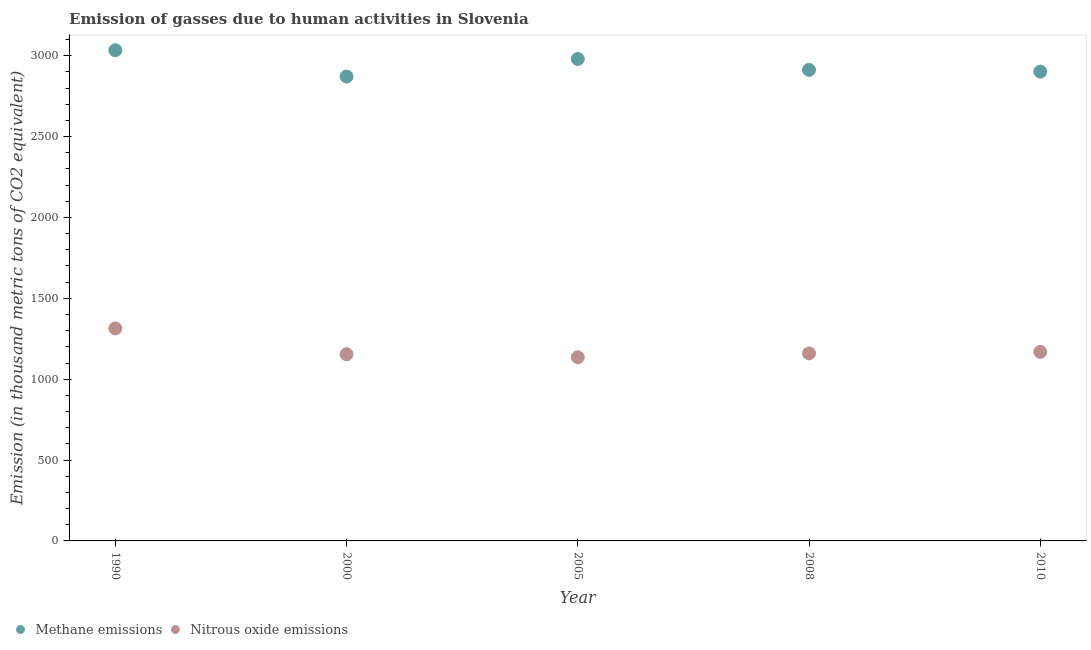How many different coloured dotlines are there?
Your response must be concise. 2. Is the number of dotlines equal to the number of legend labels?
Your response must be concise. Yes. What is the amount of methane emissions in 2010?
Offer a terse response. 2901.7. Across all years, what is the maximum amount of nitrous oxide emissions?
Keep it short and to the point. 1313.9. Across all years, what is the minimum amount of methane emissions?
Ensure brevity in your answer.  2871.1. What is the total amount of nitrous oxide emissions in the graph?
Your answer should be very brief. 5932. What is the difference between the amount of nitrous oxide emissions in 1990 and the amount of methane emissions in 2005?
Make the answer very short. -1666. What is the average amount of nitrous oxide emissions per year?
Ensure brevity in your answer.  1186.4. In the year 2005, what is the difference between the amount of nitrous oxide emissions and amount of methane emissions?
Your answer should be compact. -1844.2. What is the ratio of the amount of methane emissions in 2000 to that in 2010?
Keep it short and to the point. 0.99. Is the amount of nitrous oxide emissions in 2005 less than that in 2010?
Your answer should be very brief. Yes. What is the difference between the highest and the second highest amount of methane emissions?
Your response must be concise. 54. What is the difference between the highest and the lowest amount of methane emissions?
Offer a very short reply. 162.8. Does the amount of nitrous oxide emissions monotonically increase over the years?
Your response must be concise. No. Is the amount of nitrous oxide emissions strictly greater than the amount of methane emissions over the years?
Give a very brief answer. No. Is the amount of nitrous oxide emissions strictly less than the amount of methane emissions over the years?
Provide a short and direct response. Yes. How many years are there in the graph?
Offer a very short reply. 5. Where does the legend appear in the graph?
Offer a terse response. Bottom left. How many legend labels are there?
Offer a terse response. 2. How are the legend labels stacked?
Offer a very short reply. Horizontal. What is the title of the graph?
Keep it short and to the point. Emission of gasses due to human activities in Slovenia. What is the label or title of the Y-axis?
Provide a succinct answer. Emission (in thousand metric tons of CO2 equivalent). What is the Emission (in thousand metric tons of CO2 equivalent) in Methane emissions in 1990?
Your answer should be compact. 3033.9. What is the Emission (in thousand metric tons of CO2 equivalent) of Nitrous oxide emissions in 1990?
Offer a terse response. 1313.9. What is the Emission (in thousand metric tons of CO2 equivalent) of Methane emissions in 2000?
Give a very brief answer. 2871.1. What is the Emission (in thousand metric tons of CO2 equivalent) in Nitrous oxide emissions in 2000?
Offer a terse response. 1154.3. What is the Emission (in thousand metric tons of CO2 equivalent) in Methane emissions in 2005?
Your answer should be very brief. 2979.9. What is the Emission (in thousand metric tons of CO2 equivalent) in Nitrous oxide emissions in 2005?
Make the answer very short. 1135.7. What is the Emission (in thousand metric tons of CO2 equivalent) in Methane emissions in 2008?
Provide a short and direct response. 2912.5. What is the Emission (in thousand metric tons of CO2 equivalent) in Nitrous oxide emissions in 2008?
Give a very brief answer. 1159.5. What is the Emission (in thousand metric tons of CO2 equivalent) in Methane emissions in 2010?
Offer a very short reply. 2901.7. What is the Emission (in thousand metric tons of CO2 equivalent) of Nitrous oxide emissions in 2010?
Offer a very short reply. 1168.6. Across all years, what is the maximum Emission (in thousand metric tons of CO2 equivalent) in Methane emissions?
Your answer should be compact. 3033.9. Across all years, what is the maximum Emission (in thousand metric tons of CO2 equivalent) in Nitrous oxide emissions?
Ensure brevity in your answer.  1313.9. Across all years, what is the minimum Emission (in thousand metric tons of CO2 equivalent) of Methane emissions?
Your answer should be very brief. 2871.1. Across all years, what is the minimum Emission (in thousand metric tons of CO2 equivalent) in Nitrous oxide emissions?
Offer a very short reply. 1135.7. What is the total Emission (in thousand metric tons of CO2 equivalent) in Methane emissions in the graph?
Your answer should be very brief. 1.47e+04. What is the total Emission (in thousand metric tons of CO2 equivalent) in Nitrous oxide emissions in the graph?
Provide a succinct answer. 5932. What is the difference between the Emission (in thousand metric tons of CO2 equivalent) in Methane emissions in 1990 and that in 2000?
Offer a terse response. 162.8. What is the difference between the Emission (in thousand metric tons of CO2 equivalent) of Nitrous oxide emissions in 1990 and that in 2000?
Your answer should be compact. 159.6. What is the difference between the Emission (in thousand metric tons of CO2 equivalent) of Methane emissions in 1990 and that in 2005?
Your response must be concise. 54. What is the difference between the Emission (in thousand metric tons of CO2 equivalent) in Nitrous oxide emissions in 1990 and that in 2005?
Make the answer very short. 178.2. What is the difference between the Emission (in thousand metric tons of CO2 equivalent) of Methane emissions in 1990 and that in 2008?
Your response must be concise. 121.4. What is the difference between the Emission (in thousand metric tons of CO2 equivalent) of Nitrous oxide emissions in 1990 and that in 2008?
Your answer should be very brief. 154.4. What is the difference between the Emission (in thousand metric tons of CO2 equivalent) in Methane emissions in 1990 and that in 2010?
Ensure brevity in your answer.  132.2. What is the difference between the Emission (in thousand metric tons of CO2 equivalent) in Nitrous oxide emissions in 1990 and that in 2010?
Ensure brevity in your answer.  145.3. What is the difference between the Emission (in thousand metric tons of CO2 equivalent) in Methane emissions in 2000 and that in 2005?
Make the answer very short. -108.8. What is the difference between the Emission (in thousand metric tons of CO2 equivalent) of Methane emissions in 2000 and that in 2008?
Give a very brief answer. -41.4. What is the difference between the Emission (in thousand metric tons of CO2 equivalent) of Methane emissions in 2000 and that in 2010?
Your response must be concise. -30.6. What is the difference between the Emission (in thousand metric tons of CO2 equivalent) of Nitrous oxide emissions in 2000 and that in 2010?
Give a very brief answer. -14.3. What is the difference between the Emission (in thousand metric tons of CO2 equivalent) in Methane emissions in 2005 and that in 2008?
Your answer should be compact. 67.4. What is the difference between the Emission (in thousand metric tons of CO2 equivalent) in Nitrous oxide emissions in 2005 and that in 2008?
Ensure brevity in your answer.  -23.8. What is the difference between the Emission (in thousand metric tons of CO2 equivalent) of Methane emissions in 2005 and that in 2010?
Provide a succinct answer. 78.2. What is the difference between the Emission (in thousand metric tons of CO2 equivalent) in Nitrous oxide emissions in 2005 and that in 2010?
Ensure brevity in your answer.  -32.9. What is the difference between the Emission (in thousand metric tons of CO2 equivalent) in Methane emissions in 1990 and the Emission (in thousand metric tons of CO2 equivalent) in Nitrous oxide emissions in 2000?
Provide a succinct answer. 1879.6. What is the difference between the Emission (in thousand metric tons of CO2 equivalent) of Methane emissions in 1990 and the Emission (in thousand metric tons of CO2 equivalent) of Nitrous oxide emissions in 2005?
Provide a succinct answer. 1898.2. What is the difference between the Emission (in thousand metric tons of CO2 equivalent) of Methane emissions in 1990 and the Emission (in thousand metric tons of CO2 equivalent) of Nitrous oxide emissions in 2008?
Offer a terse response. 1874.4. What is the difference between the Emission (in thousand metric tons of CO2 equivalent) in Methane emissions in 1990 and the Emission (in thousand metric tons of CO2 equivalent) in Nitrous oxide emissions in 2010?
Offer a very short reply. 1865.3. What is the difference between the Emission (in thousand metric tons of CO2 equivalent) in Methane emissions in 2000 and the Emission (in thousand metric tons of CO2 equivalent) in Nitrous oxide emissions in 2005?
Offer a terse response. 1735.4. What is the difference between the Emission (in thousand metric tons of CO2 equivalent) in Methane emissions in 2000 and the Emission (in thousand metric tons of CO2 equivalent) in Nitrous oxide emissions in 2008?
Provide a succinct answer. 1711.6. What is the difference between the Emission (in thousand metric tons of CO2 equivalent) of Methane emissions in 2000 and the Emission (in thousand metric tons of CO2 equivalent) of Nitrous oxide emissions in 2010?
Make the answer very short. 1702.5. What is the difference between the Emission (in thousand metric tons of CO2 equivalent) of Methane emissions in 2005 and the Emission (in thousand metric tons of CO2 equivalent) of Nitrous oxide emissions in 2008?
Your response must be concise. 1820.4. What is the difference between the Emission (in thousand metric tons of CO2 equivalent) of Methane emissions in 2005 and the Emission (in thousand metric tons of CO2 equivalent) of Nitrous oxide emissions in 2010?
Give a very brief answer. 1811.3. What is the difference between the Emission (in thousand metric tons of CO2 equivalent) of Methane emissions in 2008 and the Emission (in thousand metric tons of CO2 equivalent) of Nitrous oxide emissions in 2010?
Give a very brief answer. 1743.9. What is the average Emission (in thousand metric tons of CO2 equivalent) of Methane emissions per year?
Offer a terse response. 2939.82. What is the average Emission (in thousand metric tons of CO2 equivalent) in Nitrous oxide emissions per year?
Provide a succinct answer. 1186.4. In the year 1990, what is the difference between the Emission (in thousand metric tons of CO2 equivalent) in Methane emissions and Emission (in thousand metric tons of CO2 equivalent) in Nitrous oxide emissions?
Provide a short and direct response. 1720. In the year 2000, what is the difference between the Emission (in thousand metric tons of CO2 equivalent) in Methane emissions and Emission (in thousand metric tons of CO2 equivalent) in Nitrous oxide emissions?
Ensure brevity in your answer.  1716.8. In the year 2005, what is the difference between the Emission (in thousand metric tons of CO2 equivalent) in Methane emissions and Emission (in thousand metric tons of CO2 equivalent) in Nitrous oxide emissions?
Ensure brevity in your answer.  1844.2. In the year 2008, what is the difference between the Emission (in thousand metric tons of CO2 equivalent) of Methane emissions and Emission (in thousand metric tons of CO2 equivalent) of Nitrous oxide emissions?
Provide a short and direct response. 1753. In the year 2010, what is the difference between the Emission (in thousand metric tons of CO2 equivalent) of Methane emissions and Emission (in thousand metric tons of CO2 equivalent) of Nitrous oxide emissions?
Offer a very short reply. 1733.1. What is the ratio of the Emission (in thousand metric tons of CO2 equivalent) of Methane emissions in 1990 to that in 2000?
Keep it short and to the point. 1.06. What is the ratio of the Emission (in thousand metric tons of CO2 equivalent) of Nitrous oxide emissions in 1990 to that in 2000?
Offer a very short reply. 1.14. What is the ratio of the Emission (in thousand metric tons of CO2 equivalent) in Methane emissions in 1990 to that in 2005?
Make the answer very short. 1.02. What is the ratio of the Emission (in thousand metric tons of CO2 equivalent) of Nitrous oxide emissions in 1990 to that in 2005?
Provide a succinct answer. 1.16. What is the ratio of the Emission (in thousand metric tons of CO2 equivalent) of Methane emissions in 1990 to that in 2008?
Give a very brief answer. 1.04. What is the ratio of the Emission (in thousand metric tons of CO2 equivalent) in Nitrous oxide emissions in 1990 to that in 2008?
Provide a succinct answer. 1.13. What is the ratio of the Emission (in thousand metric tons of CO2 equivalent) in Methane emissions in 1990 to that in 2010?
Offer a terse response. 1.05. What is the ratio of the Emission (in thousand metric tons of CO2 equivalent) in Nitrous oxide emissions in 1990 to that in 2010?
Your response must be concise. 1.12. What is the ratio of the Emission (in thousand metric tons of CO2 equivalent) in Methane emissions in 2000 to that in 2005?
Offer a terse response. 0.96. What is the ratio of the Emission (in thousand metric tons of CO2 equivalent) in Nitrous oxide emissions in 2000 to that in 2005?
Provide a short and direct response. 1.02. What is the ratio of the Emission (in thousand metric tons of CO2 equivalent) in Methane emissions in 2000 to that in 2008?
Your answer should be compact. 0.99. What is the ratio of the Emission (in thousand metric tons of CO2 equivalent) in Methane emissions in 2000 to that in 2010?
Your answer should be very brief. 0.99. What is the ratio of the Emission (in thousand metric tons of CO2 equivalent) of Methane emissions in 2005 to that in 2008?
Ensure brevity in your answer.  1.02. What is the ratio of the Emission (in thousand metric tons of CO2 equivalent) of Nitrous oxide emissions in 2005 to that in 2008?
Provide a succinct answer. 0.98. What is the ratio of the Emission (in thousand metric tons of CO2 equivalent) in Methane emissions in 2005 to that in 2010?
Make the answer very short. 1.03. What is the ratio of the Emission (in thousand metric tons of CO2 equivalent) of Nitrous oxide emissions in 2005 to that in 2010?
Give a very brief answer. 0.97. What is the difference between the highest and the second highest Emission (in thousand metric tons of CO2 equivalent) of Nitrous oxide emissions?
Give a very brief answer. 145.3. What is the difference between the highest and the lowest Emission (in thousand metric tons of CO2 equivalent) in Methane emissions?
Your answer should be very brief. 162.8. What is the difference between the highest and the lowest Emission (in thousand metric tons of CO2 equivalent) of Nitrous oxide emissions?
Provide a short and direct response. 178.2. 